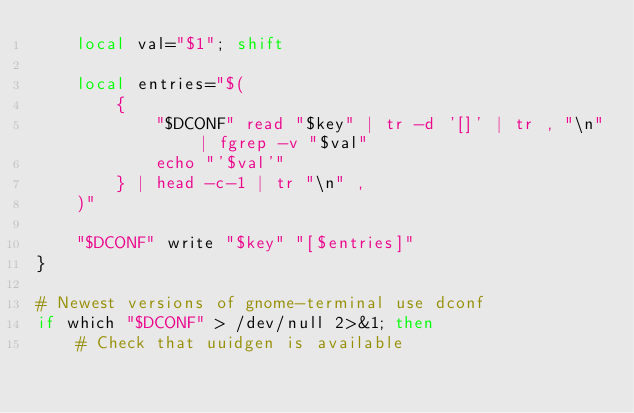<code> <loc_0><loc_0><loc_500><loc_500><_Bash_>    local val="$1"; shift

    local entries="$(
        {
            "$DCONF" read "$key" | tr -d '[]' | tr , "\n" | fgrep -v "$val"
            echo "'$val'"
        } | head -c-1 | tr "\n" ,
    )"

    "$DCONF" write "$key" "[$entries]"
}

# Newest versions of gnome-terminal use dconf
if which "$DCONF" > /dev/null 2>&1; then
    # Check that uuidgen is available</code> 